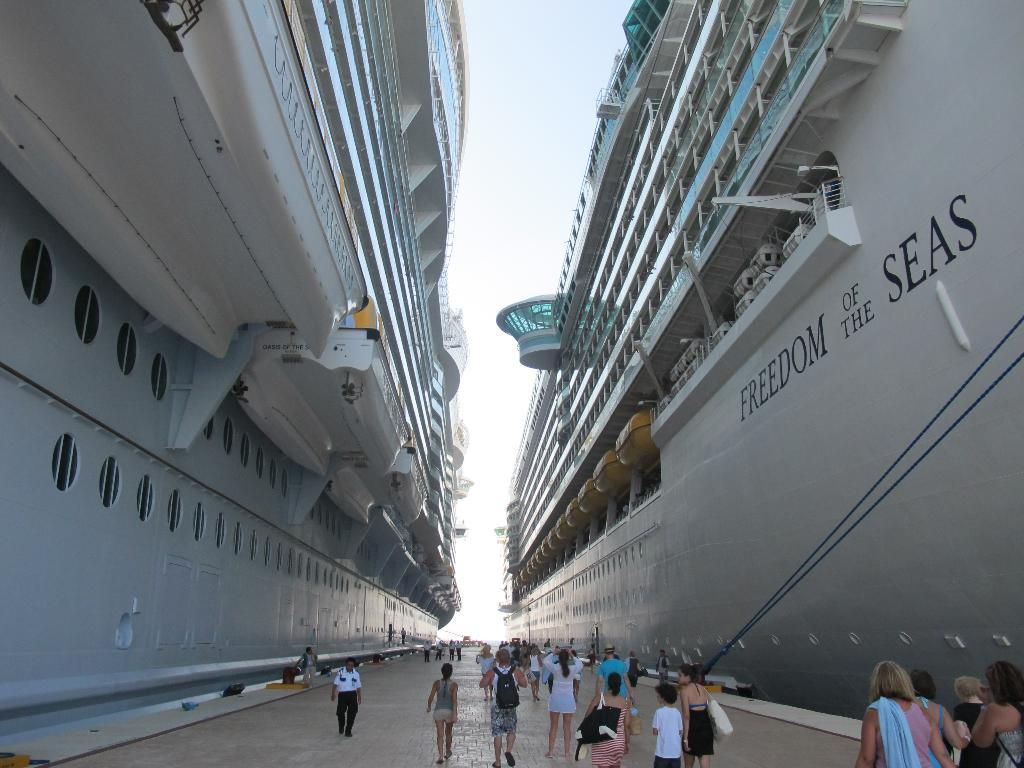<image>
Relay a brief, clear account of the picture shown. People walk between Freedom of the Seas and another cruise ship. 